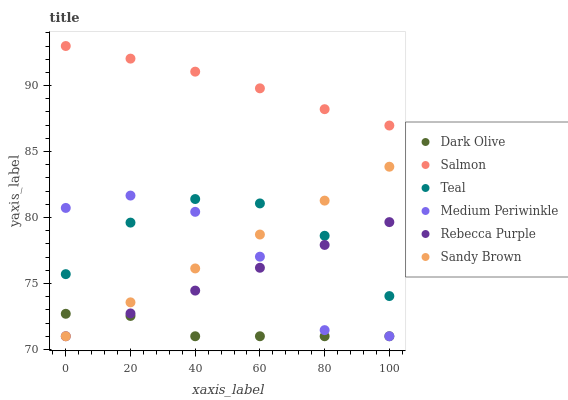Does Dark Olive have the minimum area under the curve?
Answer yes or no. Yes. Does Salmon have the maximum area under the curve?
Answer yes or no. Yes. Does Medium Periwinkle have the minimum area under the curve?
Answer yes or no. No. Does Medium Periwinkle have the maximum area under the curve?
Answer yes or no. No. Is Rebecca Purple the smoothest?
Answer yes or no. Yes. Is Medium Periwinkle the roughest?
Answer yes or no. Yes. Is Dark Olive the smoothest?
Answer yes or no. No. Is Dark Olive the roughest?
Answer yes or no. No. Does Dark Olive have the lowest value?
Answer yes or no. Yes. Does Teal have the lowest value?
Answer yes or no. No. Does Salmon have the highest value?
Answer yes or no. Yes. Does Medium Periwinkle have the highest value?
Answer yes or no. No. Is Dark Olive less than Teal?
Answer yes or no. Yes. Is Salmon greater than Dark Olive?
Answer yes or no. Yes. Does Dark Olive intersect Rebecca Purple?
Answer yes or no. Yes. Is Dark Olive less than Rebecca Purple?
Answer yes or no. No. Is Dark Olive greater than Rebecca Purple?
Answer yes or no. No. Does Dark Olive intersect Teal?
Answer yes or no. No. 